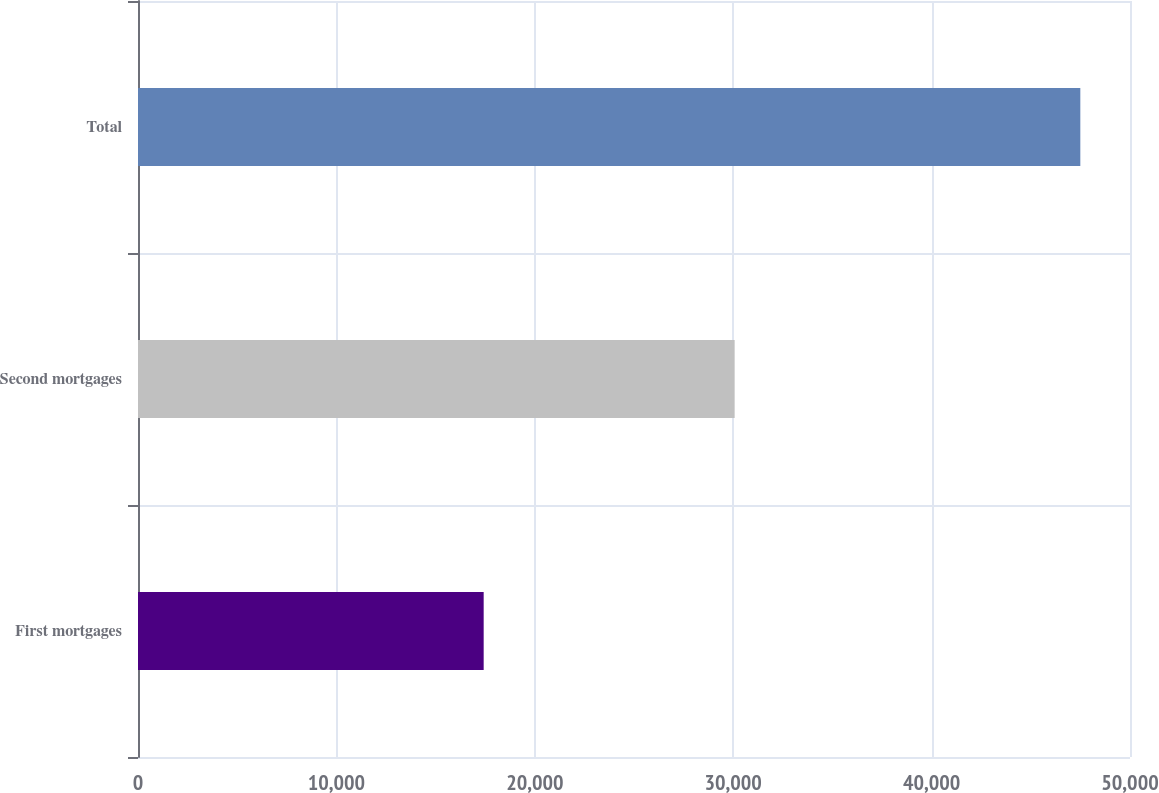<chart> <loc_0><loc_0><loc_500><loc_500><bar_chart><fcel>First mortgages<fcel>Second mortgages<fcel>Total<nl><fcel>17423<fcel>30073<fcel>47496<nl></chart> 